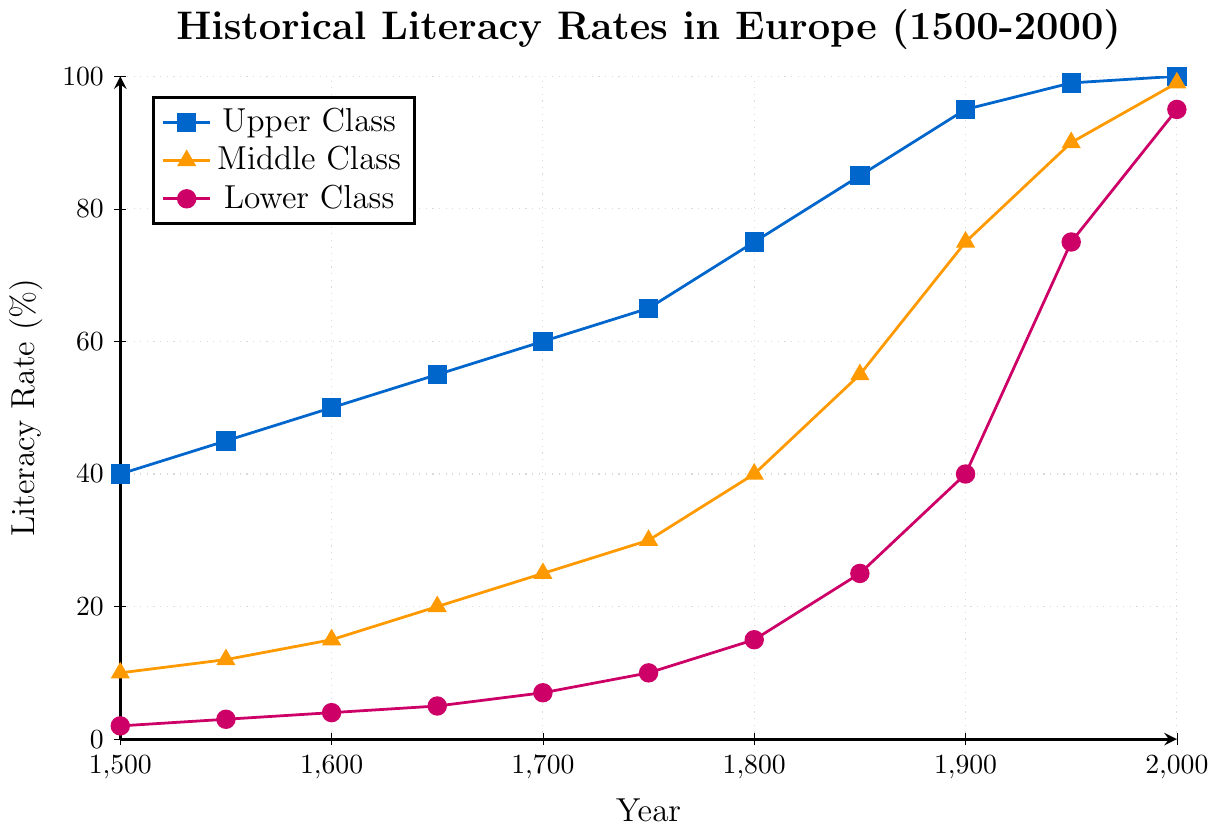What is the literacy rate of the lower class in the year 1850? First, identify the appropriate data point for the lower class in the year 1850, which is marked with a color and symbol. According to the figure, this rate is 25%.
Answer: 25% From 1500 to 2000, by how much did the literacy rate of the middle class increase? Find the literacy rates of the middle class in 1500 and 2000, which are 10% and 99%, respectively. Subtract the initial rate from the final rate: 99% - 10% = 89%.
Answer: 89% During which century did the upper class experience the steepest increase in literacy rates? Observe the slope of the line associated with the upper class. The steepest increase occurs between 1800 and 1850, which is the 19th century.
Answer: 19th century Compare the literacy rate difference between the middle and lower classes in the year 1950. Identify the literacy rates for both classes in 1950: 90% for the middle class and 75% for the lower class. Subtract the lower class rate from the middle class rate: 90% - 75% = 15%.
Answer: 15% In which year did the upper class achieve a literacy rate of 85%? Trace the line for the upper class to locate the year when its literacy rate first reached 85%. This occurs in the year 1850.
Answer: 1850 Which social class had a literacy rate of 40% first, and in which year? Identify the literacy rates for all classes over time. The upper class reached 40% in 1500, the middle class in 1800, and the lower class in 1900. The first to reach 40% was the upper class in 1500.
Answer: Upper class, 1500 How did the literacy rate of the lower class evolve between 1700 and 1800? Determine the literacy rates for the lower class in 1700 and 1800, which are 7% and 15%. The rate increased by 8% (15% - 7%) over this period.
Answer: Increased by 8% By the year 2000, how close was the lower class literacy rate to that of the middle class? Locate the literacy rates for both classes in 2000: 99% for the middle class and 95% for the lower class. The difference between them is 99% - 95% = 4%. Hence, they were 4% apart.
Answer: 4% What is the average literacy rate increase per century for the upper class from 1500 to 2000? The literacy rate of the upper class increased from 40% to 100% over 500 years. The total increase is 100% - 40% = 60%. Dividing by five centuries, the average per century is 60% / 5 = 12%.
Answer: 12% 